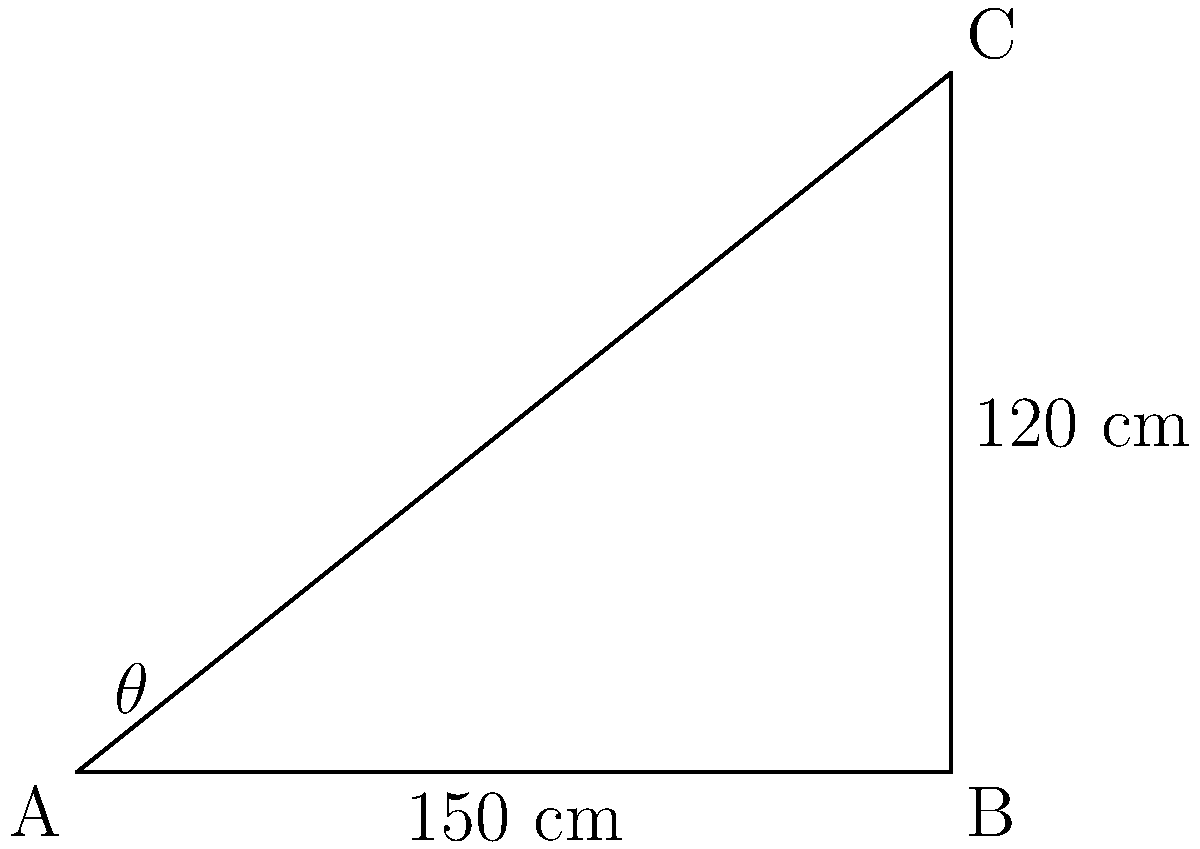An adjustable desk needs to be designed for optimal ergonomics. The desk surface (AC) can be tilted, with point A fixed and point C movable. If the desk's width (AB) is 150 cm and its maximum height (BC) is 120 cm, what is the maximum angle $\theta$ that the desk surface can make with the horizontal? To solve this problem, we'll use trigonometry, specifically the arctangent function. Here's the step-by-step solution:

1) We have a right-angled triangle ABC, where:
   AB (width) = 150 cm
   BC (height) = 120 cm

2) The angle $\theta$ we're looking for is the angle between AB and AC.

3) In a right-angled triangle, $\tan(\theta) = \frac{\text{opposite}}{\text{adjacent}}$

4) In this case:
   opposite = BC = 120 cm
   adjacent = AB = 150 cm

5) So, $\tan(\theta) = \frac{120}{150} = \frac{4}{5} = 0.8$

6) To find $\theta$, we need to use the inverse tangent (arctangent) function:

   $\theta = \arctan(0.8)$

7) Using a calculator or computer:

   $\theta \approx 38.66$ degrees

8) Rounding to the nearest degree:

   $\theta \approx 39$ degrees

This angle represents the maximum tilt of the desk surface for optimal ergonomics and accessibility.
Answer: 39° 